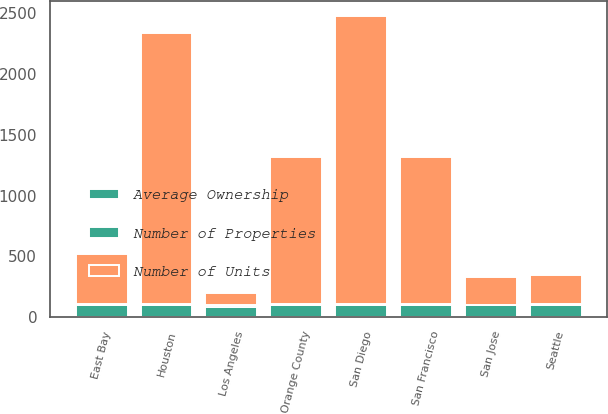<chart> <loc_0><loc_0><loc_500><loc_500><stacked_bar_chart><ecel><fcel>Los Angeles<fcel>Orange County<fcel>San Diego<fcel>East Bay<fcel>San Jose<fcel>San Francisco<fcel>Seattle<fcel>Houston<nl><fcel>Number of Properties<fcel>13<fcel>4<fcel>11<fcel>2<fcel>1<fcel>7<fcel>2<fcel>5<nl><fcel>Number of Units<fcel>100<fcel>1213<fcel>2370<fcel>413<fcel>224<fcel>1208<fcel>239<fcel>2237<nl><fcel>Average Ownership<fcel>85<fcel>100<fcel>97<fcel>100<fcel>100<fcel>100<fcel>100<fcel>97<nl></chart> 